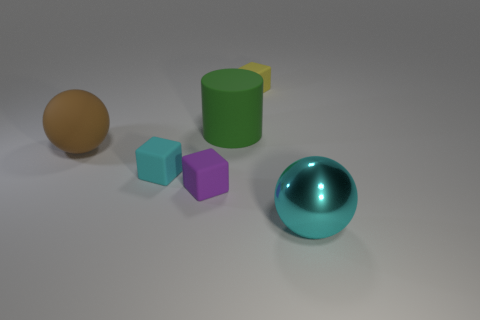Add 3 large rubber things. How many objects exist? 9 Subtract all balls. How many objects are left? 4 Add 5 large brown spheres. How many large brown spheres exist? 6 Subtract 0 cyan cylinders. How many objects are left? 6 Subtract all tiny purple rubber blocks. Subtract all big green things. How many objects are left? 4 Add 3 green objects. How many green objects are left? 4 